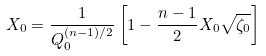<formula> <loc_0><loc_0><loc_500><loc_500>X _ { 0 } = \frac { 1 } { Q _ { 0 } ^ { ( n - 1 ) / 2 } } \left [ 1 - \frac { n - 1 } { 2 } X _ { 0 } \sqrt { \zeta _ { 0 } } \right ]</formula> 